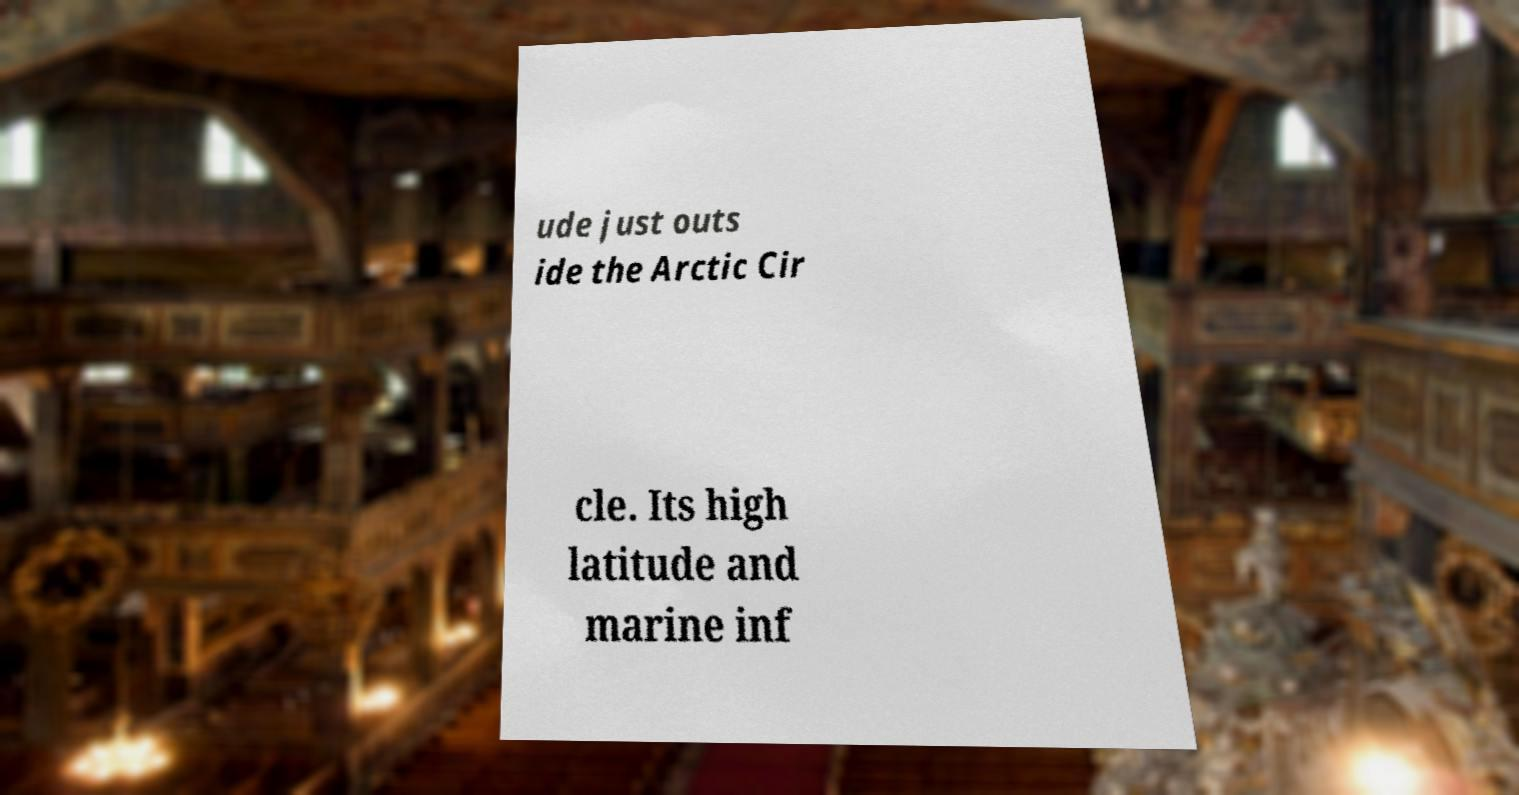I need the written content from this picture converted into text. Can you do that? ude just outs ide the Arctic Cir cle. Its high latitude and marine inf 